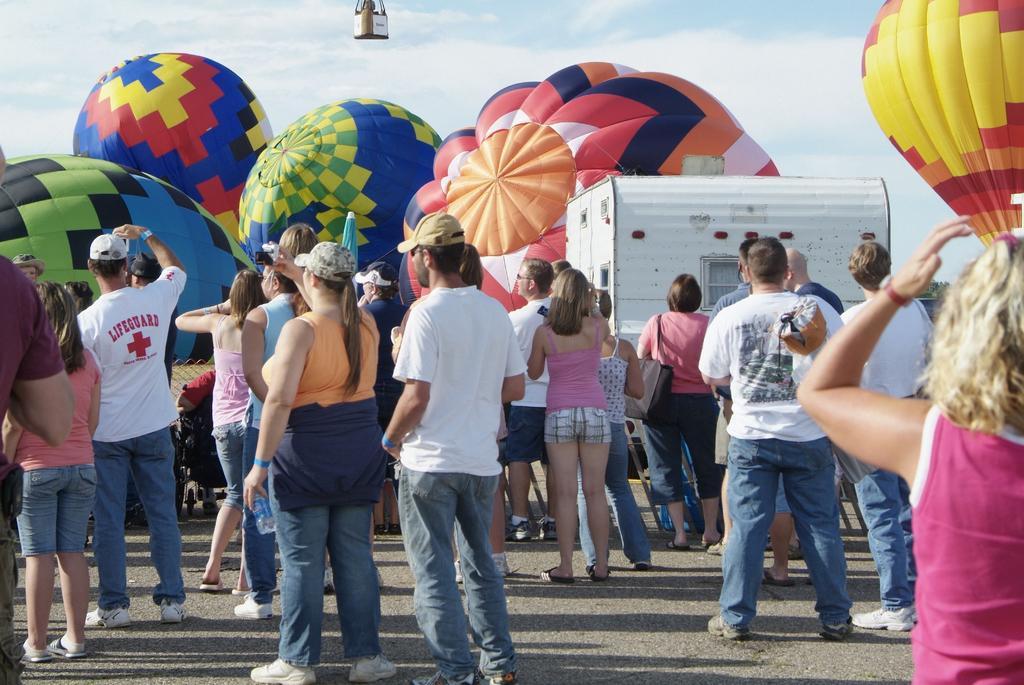Describe this image in one or two sentences. In this image there are people standing and we can see parachutes. In the background there is sky. 